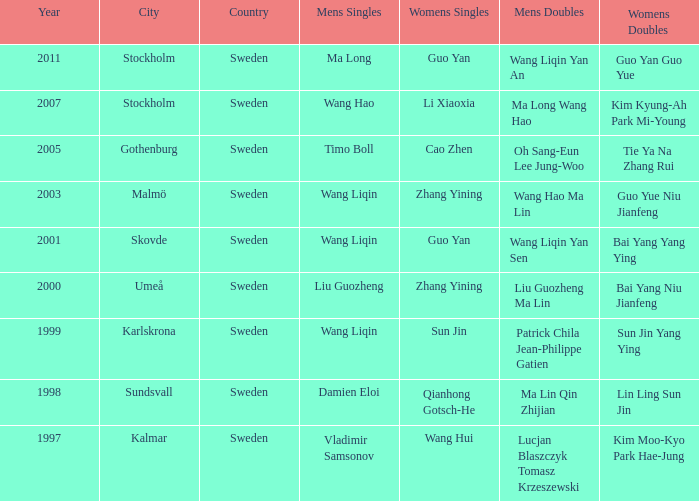What is the place and when was the year when the women's doubles womens were Bai yang Niu Jianfeng? 2000 Umeå. 